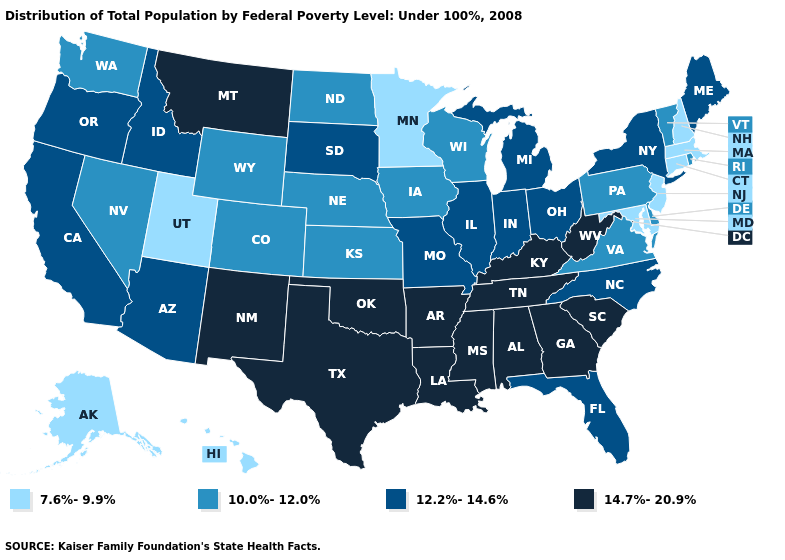Name the states that have a value in the range 12.2%-14.6%?
Concise answer only. Arizona, California, Florida, Idaho, Illinois, Indiana, Maine, Michigan, Missouri, New York, North Carolina, Ohio, Oregon, South Dakota. Among the states that border California , does Arizona have the lowest value?
Concise answer only. No. Name the states that have a value in the range 12.2%-14.6%?
Answer briefly. Arizona, California, Florida, Idaho, Illinois, Indiana, Maine, Michigan, Missouri, New York, North Carolina, Ohio, Oregon, South Dakota. Name the states that have a value in the range 12.2%-14.6%?
Write a very short answer. Arizona, California, Florida, Idaho, Illinois, Indiana, Maine, Michigan, Missouri, New York, North Carolina, Ohio, Oregon, South Dakota. What is the lowest value in states that border New York?
Answer briefly. 7.6%-9.9%. Which states hav the highest value in the MidWest?
Concise answer only. Illinois, Indiana, Michigan, Missouri, Ohio, South Dakota. Does Arizona have the lowest value in the West?
Keep it brief. No. Name the states that have a value in the range 7.6%-9.9%?
Keep it brief. Alaska, Connecticut, Hawaii, Maryland, Massachusetts, Minnesota, New Hampshire, New Jersey, Utah. Among the states that border South Carolina , which have the highest value?
Keep it brief. Georgia. Does New Jersey have the lowest value in the USA?
Quick response, please. Yes. Which states have the lowest value in the West?
Concise answer only. Alaska, Hawaii, Utah. What is the value of North Carolina?
Answer briefly. 12.2%-14.6%. Does Minnesota have the lowest value in the USA?
Short answer required. Yes. What is the value of Kentucky?
Short answer required. 14.7%-20.9%. Among the states that border North Dakota , does Montana have the highest value?
Short answer required. Yes. 